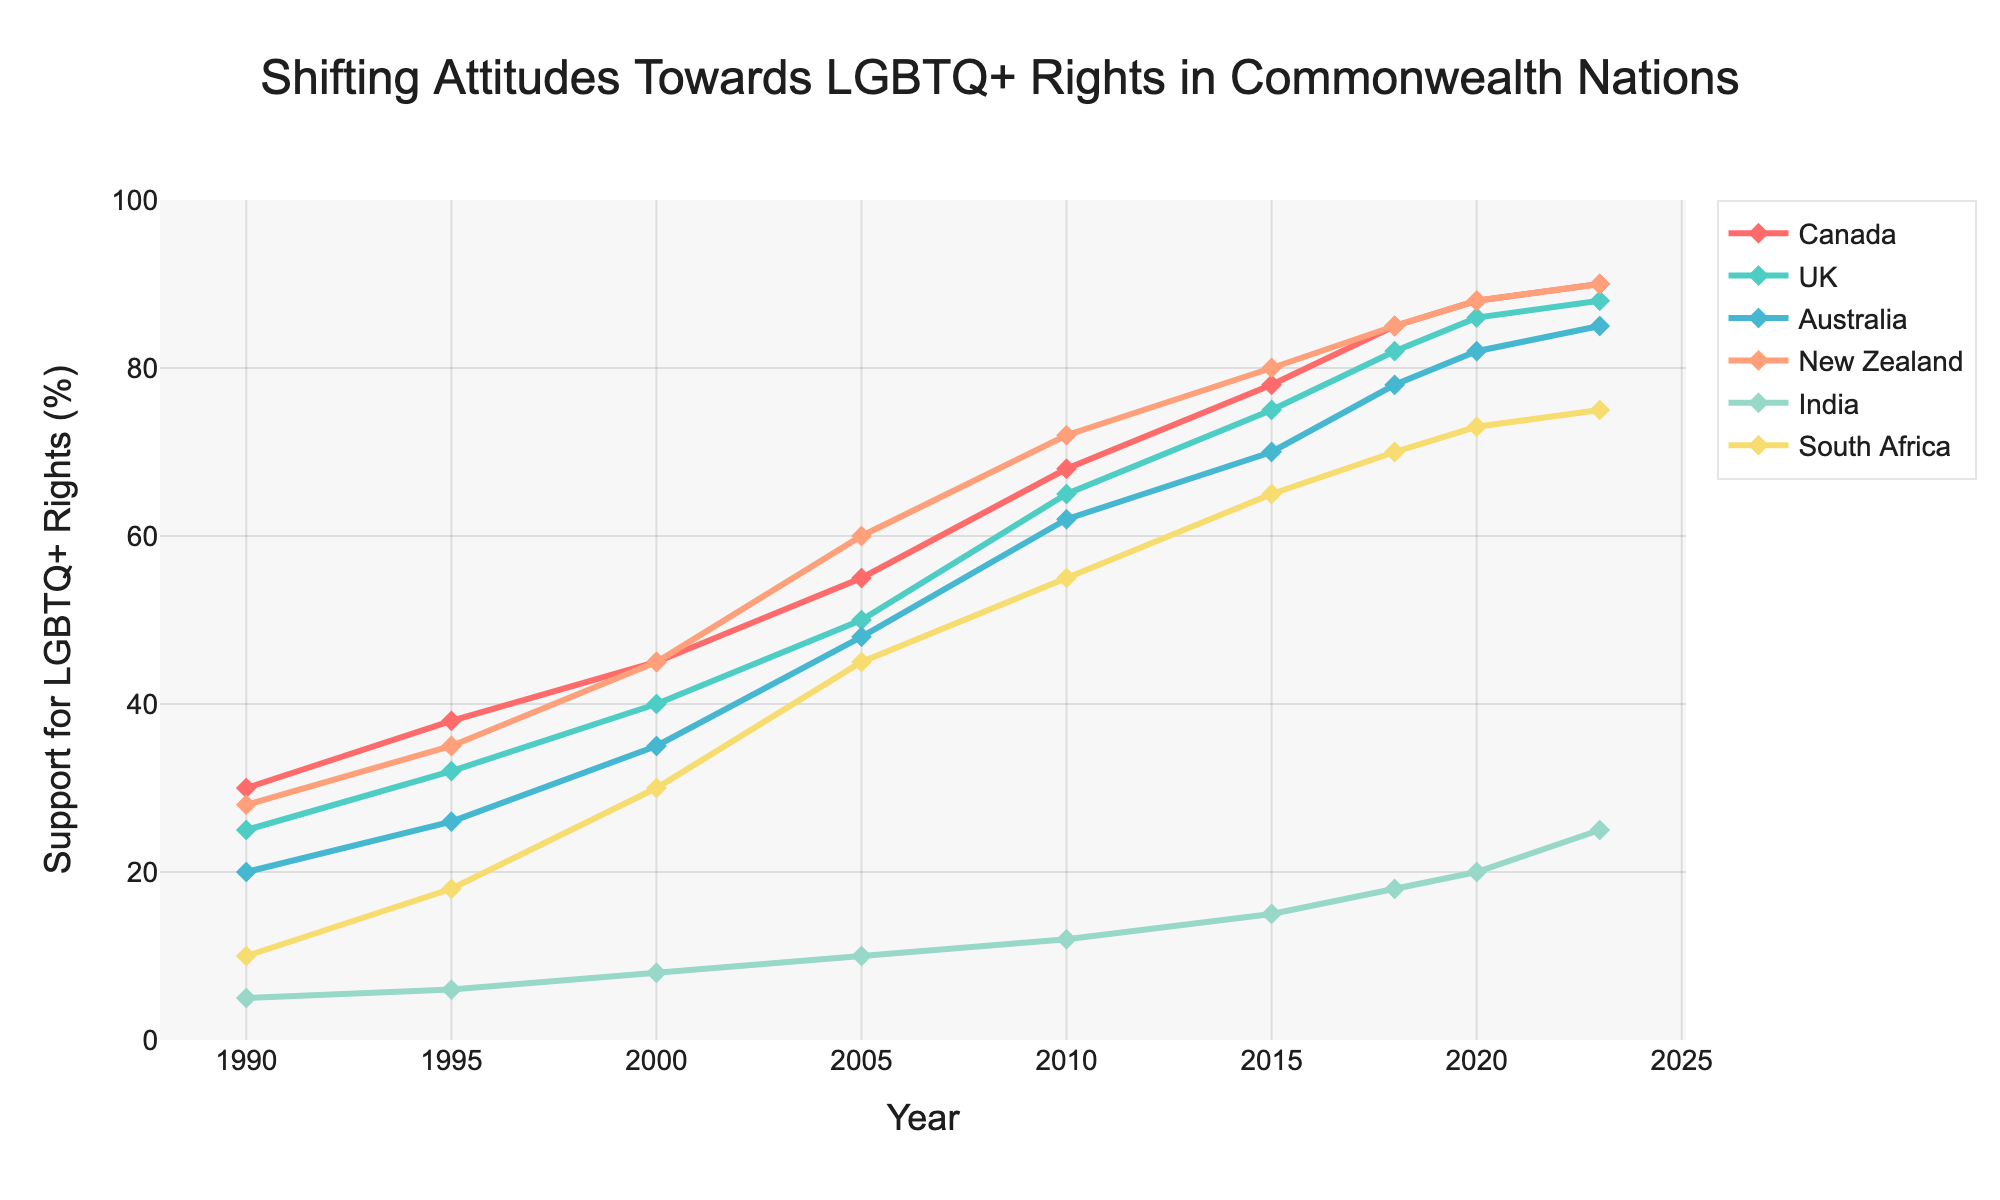how did the attitudes towards LGBTQ+ rights in India change from 1990 to 2023? In 1990, the support for LGBTQ+ rights in India was 5%, and by 2023 it increased to 25%. Thus, the change is 25% - 5% = 20%.
Answer: 20% Which country had the highest increase in support for LGBTQ+ rights from 1990 to 2023? To find the highest increase, we subtract the 1990 values from the 2023 values for each country: Canada (90-30=60), UK (88-25=63), Australia (85-20=65), New Zealand (90-28=62), India (25-5=20), South Africa (75-10=65). Comparing these, Australia and South Africa both have the highest increase of 65%.
Answer: Australia and South Africa In which year did New Zealand surpass 70% support for LGBTQ+ rights? Checking New Zealand's support over the years, it exceeded 70% support in 2010 when it reached 72%.
Answer: 2010 How does the support for LGBTQ+ rights in South Africa in 2023 compare with the support in Canada in 2000? In 2023, South Africa had 75% support, while Canada had 45% support in 2000. Thus, South Africa in 2023 is higher by 75% - 45% = 30%.
Answer: South Africa 2023 is 30% higher What is the average support for LGBTQ+ rights in the Commonwealth nations in 2023? To find the average, add the support percentages of all the nations in 2023: (90 + 88 + 85 + 90 + 25 + 75) = 453. Then divide by the number of countries: 453 / 6 ≈ 75.5%.
Answer: 75.5% Which country had the least change in support for LGBTQ+ rights, and what was the change? To find the least change, subtract the 1990 values from the 2023 values for each country and find the smallest difference. India had the smallest change (25 - 5 = 20).
Answer: India, 20% Did the support for LGBTQ+ rights in the UK surpass that of Australia, and if so, when? From the data, UK support surpassed Australia's in 2018 when the UK had 82% compared to Australia's 78%.
Answer: 2018 Which country's support line is represented by the green color in the figure, and what does it indicate about its support trend? Green is assigned to New Zealand. Its trend shows a consistent increase in support for LGBTQ+ rights from 1990 to 2023.
Answer: New Zealand, consistent increase 